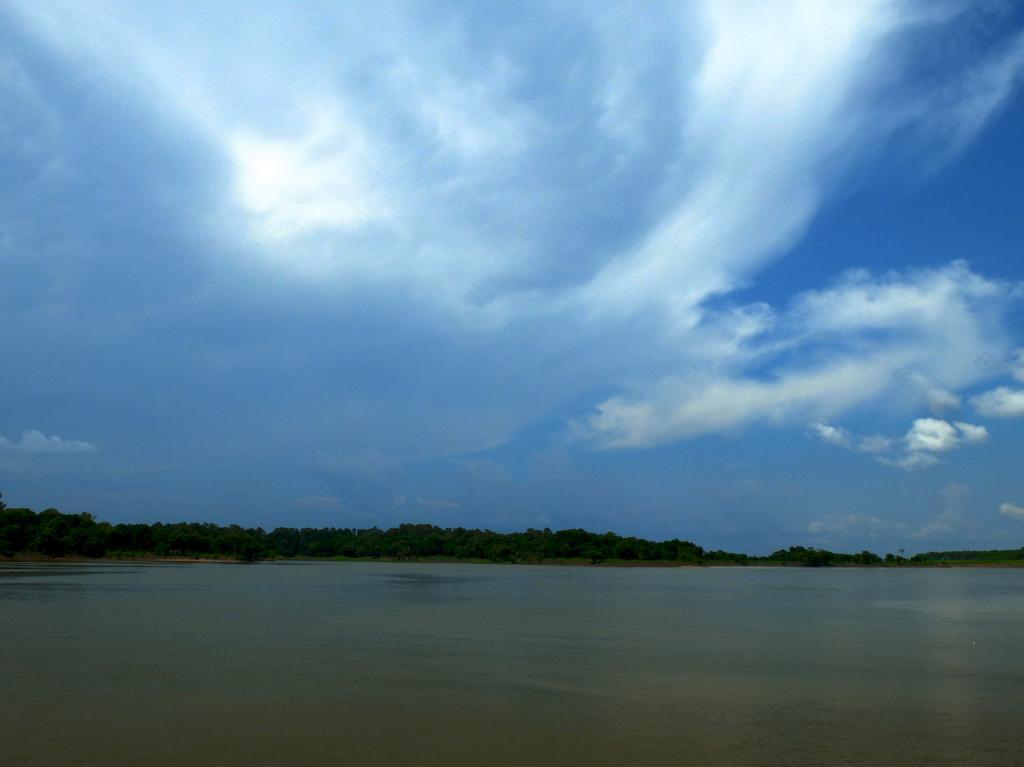Please provide a concise description of this image. In this image there is a sea, behind the sea, there are trees, at the top of the image there are clouds in the sky. 